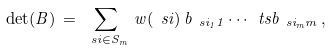<formula> <loc_0><loc_0><loc_500><loc_500>\det ( B ) \, = \, \sum _ { \ s i \in S _ { m } } \, w ( \ s i ) \, b _ { \ s i _ { 1 } { 1 } } \cdots \ t s b _ { \ s i _ { m } m } \, ,</formula> 